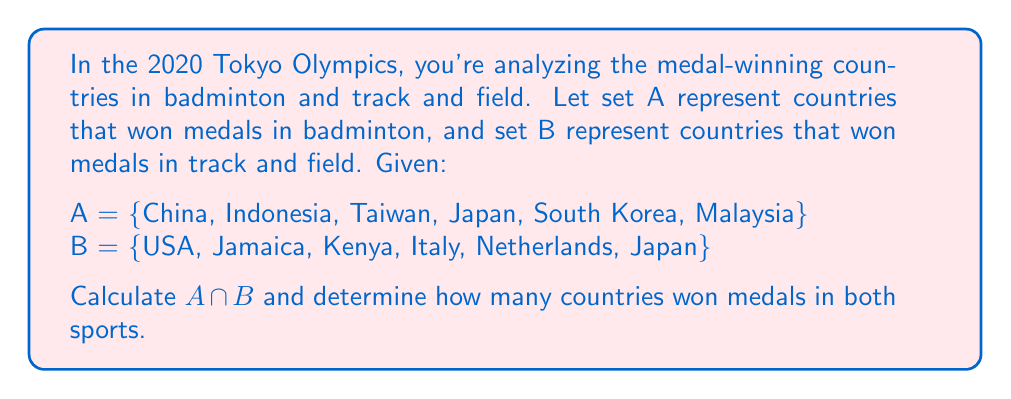Solve this math problem. To solve this problem, we need to follow these steps:

1) Recall that the intersection of two sets, denoted as $A \cap B$, is the set of all elements that are common to both A and B.

2) We need to identify which countries appear in both set A and set B.

3) Comparing the elements of both sets:

   A = {China, Indonesia, Taiwan, Japan, South Korea, Malaysia}
   B = {USA, Jamaica, Kenya, Italy, Netherlands, Japan}

   We can see that Japan is the only country that appears in both sets.

4) Therefore, $A \cap B = \{Japan\}$

5) To determine how many countries won medals in both sports, we simply need to count the number of elements in $A \cap B$.

   $|A \cap B| = 1$

This means that only one country won medals in both badminton and track and field.
Answer: $A \cap B = \{Japan\}$
Number of countries that won medals in both sports: 1 